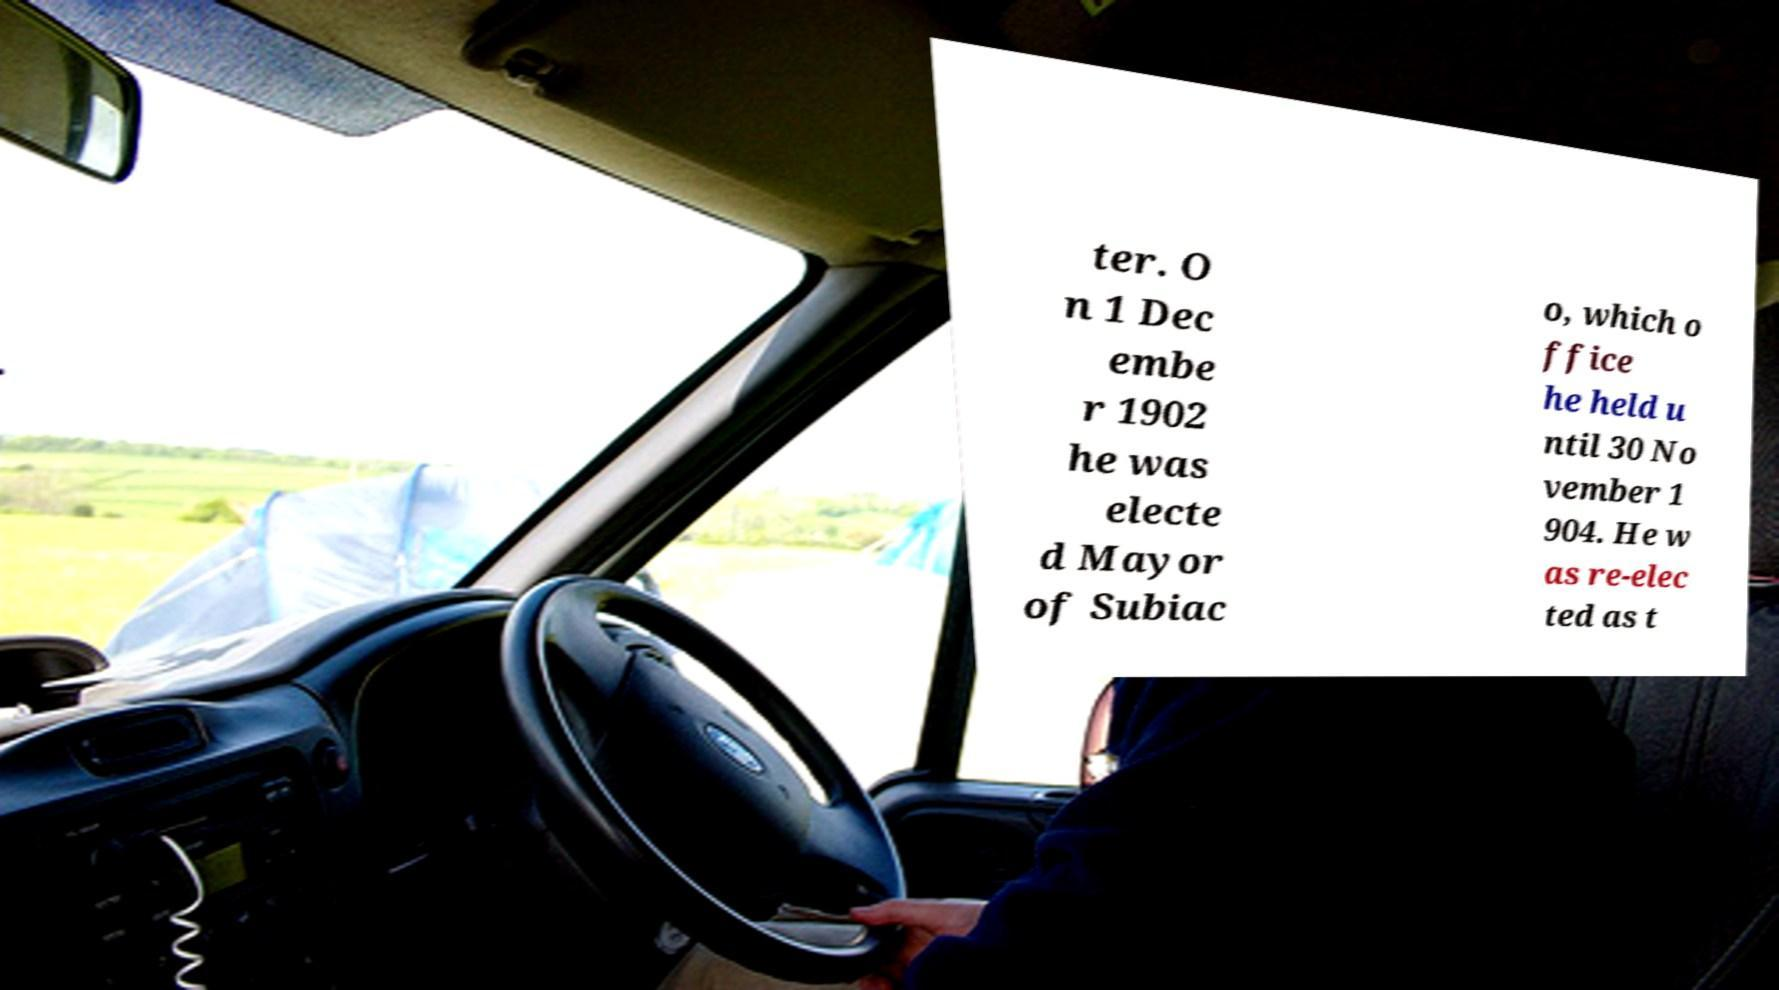Could you assist in decoding the text presented in this image and type it out clearly? ter. O n 1 Dec embe r 1902 he was electe d Mayor of Subiac o, which o ffice he held u ntil 30 No vember 1 904. He w as re-elec ted as t 